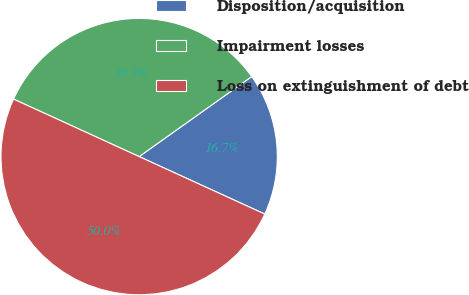Convert chart to OTSL. <chart><loc_0><loc_0><loc_500><loc_500><pie_chart><fcel>Disposition/acquisition<fcel>Impairment losses<fcel>Loss on extinguishment of debt<nl><fcel>16.67%<fcel>33.33%<fcel>50.0%<nl></chart> 